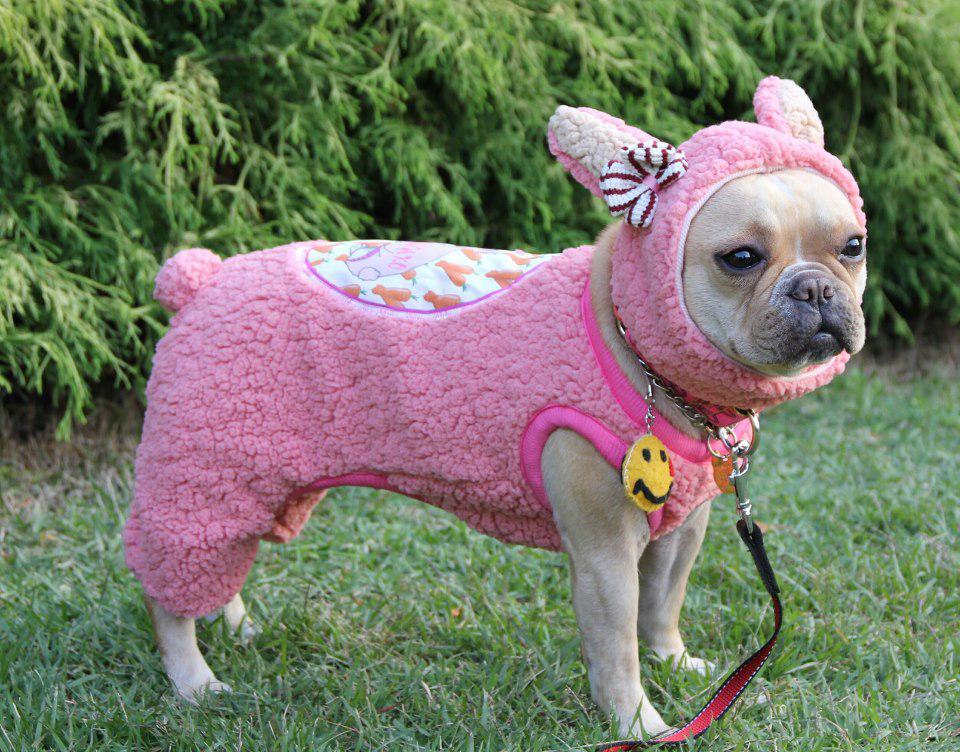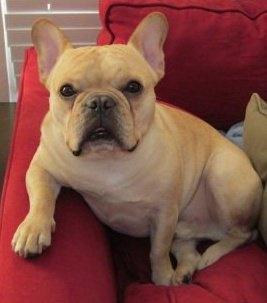The first image is the image on the left, the second image is the image on the right. Evaluate the accuracy of this statement regarding the images: "The dog in the left image is being touched by a human hand.". Is it true? Answer yes or no. No. The first image is the image on the left, the second image is the image on the right. Considering the images on both sides, is "A dog's ears are covered by articles of clothing." valid? Answer yes or no. Yes. 